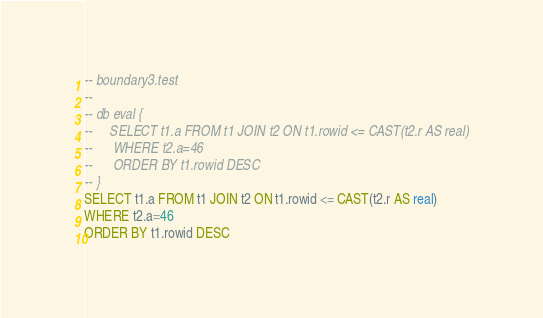<code> <loc_0><loc_0><loc_500><loc_500><_SQL_>-- boundary3.test
-- 
-- db eval {
--     SELECT t1.a FROM t1 JOIN t2 ON t1.rowid <= CAST(t2.r AS real)
--      WHERE t2.a=46
--      ORDER BY t1.rowid DESC
-- }
SELECT t1.a FROM t1 JOIN t2 ON t1.rowid <= CAST(t2.r AS real)
WHERE t2.a=46
ORDER BY t1.rowid DESC</code> 